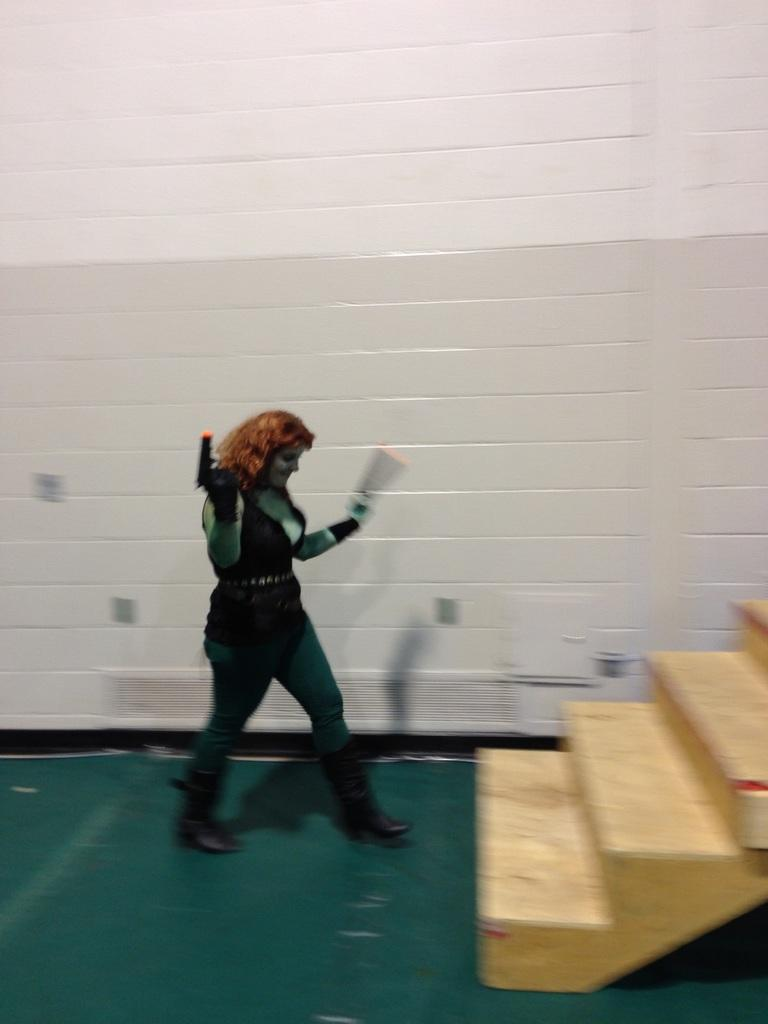What is the woman in the image holding? The woman is holding a gun in the image. What can be found at the bottom of the image? There is an object at the bottom of the image. What is visible in the background of the image? There is a wall in the background of the image. What architectural feature is on the right side of the image? There are stairs on the right side of the image. What type of grape is the woman eating in the image? There is no grape present in the image, and the woman is holding a gun, not eating anything. How many bananas can be seen on the stairs in the image? There are no bananas present in the image, and the stairs are on the right side, not the left. 